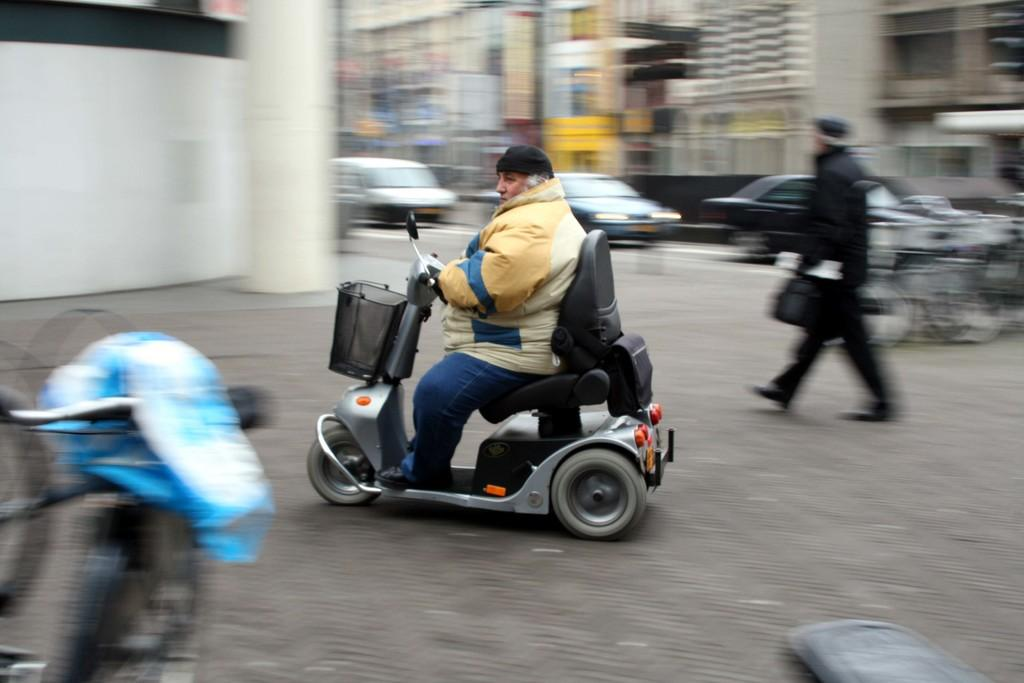What is the man in the image doing? The man is sitting in the image and holding a scooter. Can you describe the person in the image who is not sitting? There is a person walking in the image. What can be seen in the background of the image? The background of the image is blurry, and cars are visible on the road. What type of juice is the man drinking in the image? There is no juice present in the image; the man is holding a scooter. What kind of meat is being cooked in the image? There is no meat or cooking activity present in the image. 